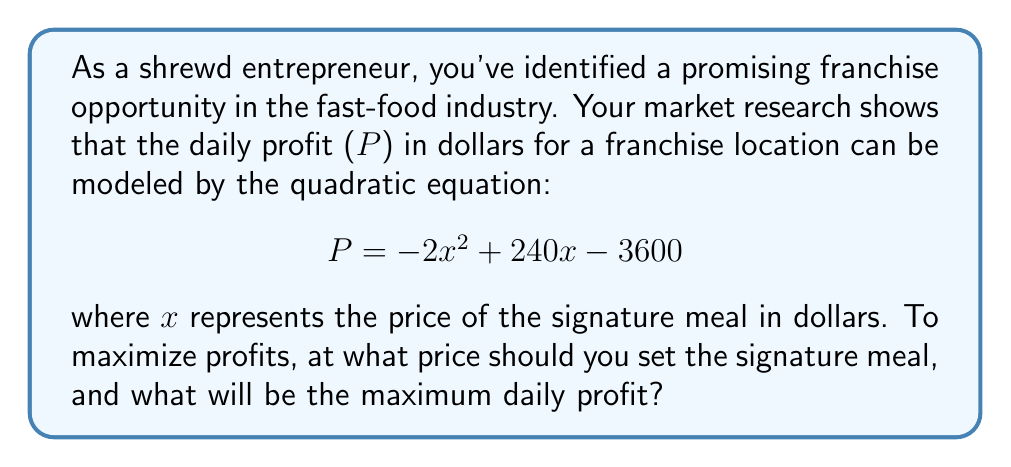Could you help me with this problem? To solve this problem, we need to find the vertex of the parabola represented by the quadratic equation. The vertex will give us the maximum profit and the corresponding price.

1. The quadratic equation is in the form $f(x) = ax^2 + bx + c$, where:
   $a = -2$, $b = 240$, and $c = -3600$

2. To find the x-coordinate of the vertex, we use the formula: $x = -\frac{b}{2a}$

   $x = -\frac{240}{2(-2)} = -\frac{240}{-4} = 60$

3. To find the y-coordinate (maximum profit), we substitute x = 60 into the original equation:

   $P = -2(60)^2 + 240(60) - 3600$
   $= -2(3600) + 14400 - 3600$
   $= -7200 + 14400 - 3600$
   $= 3600$

4. Therefore, the maximum profit occurs when the price of the signature meal is $60, and the maximum daily profit is $3600.

To verify this is indeed a maximum (not a minimum), we can check that $a < 0$ in the original equation, which confirms the parabola opens downward.
Answer: The optimal price for the signature meal is $60, which will result in a maximum daily profit of $3600. 